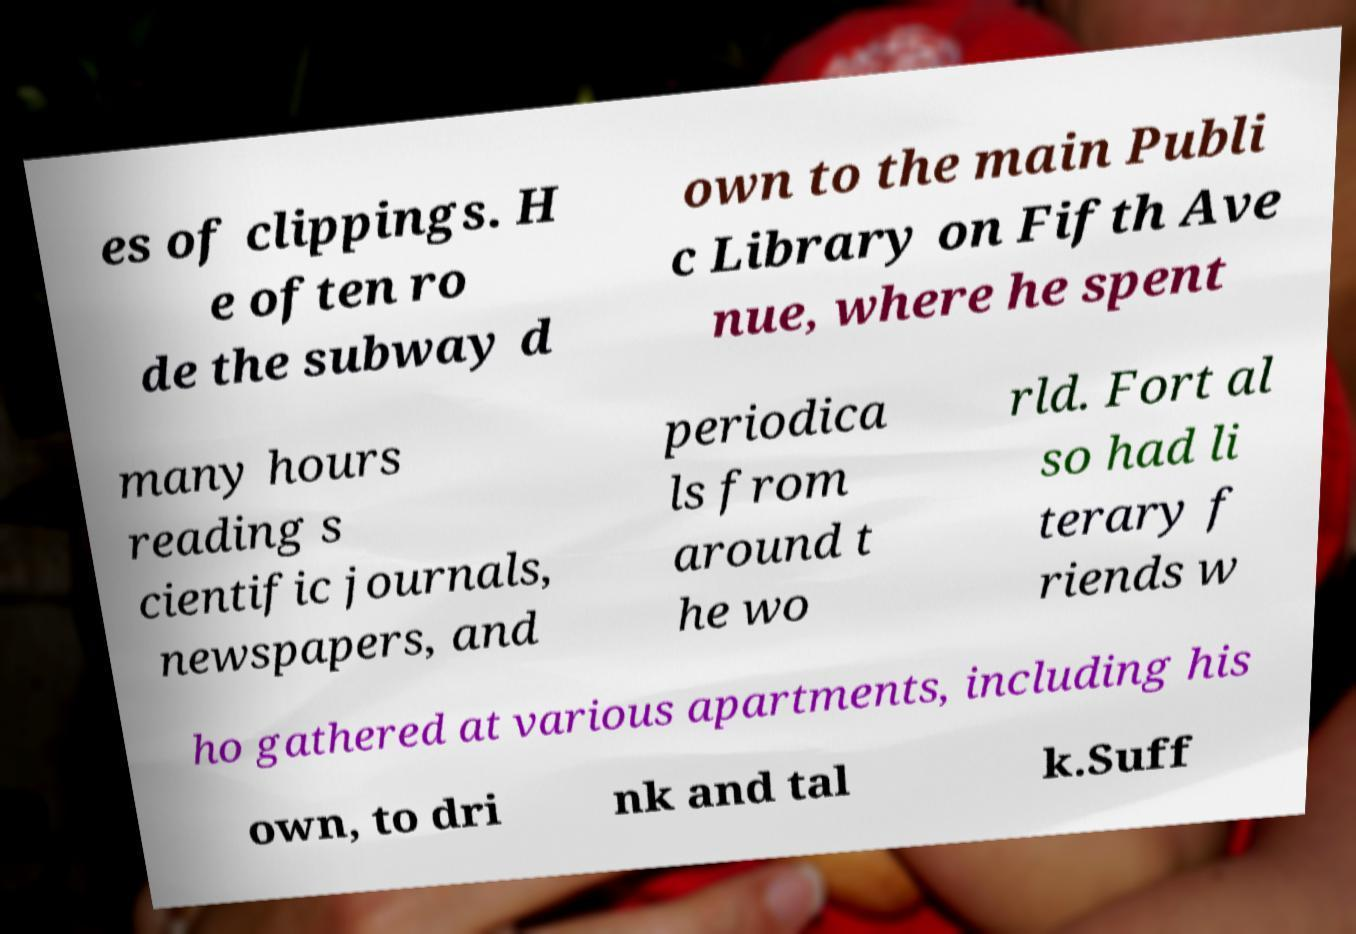Could you extract and type out the text from this image? es of clippings. H e often ro de the subway d own to the main Publi c Library on Fifth Ave nue, where he spent many hours reading s cientific journals, newspapers, and periodica ls from around t he wo rld. Fort al so had li terary f riends w ho gathered at various apartments, including his own, to dri nk and tal k.Suff 